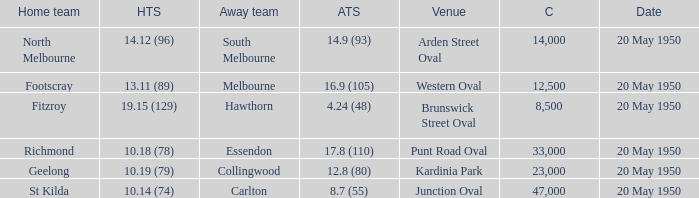What was the venue when the away team scored 14.9 (93)? Arden Street Oval. 